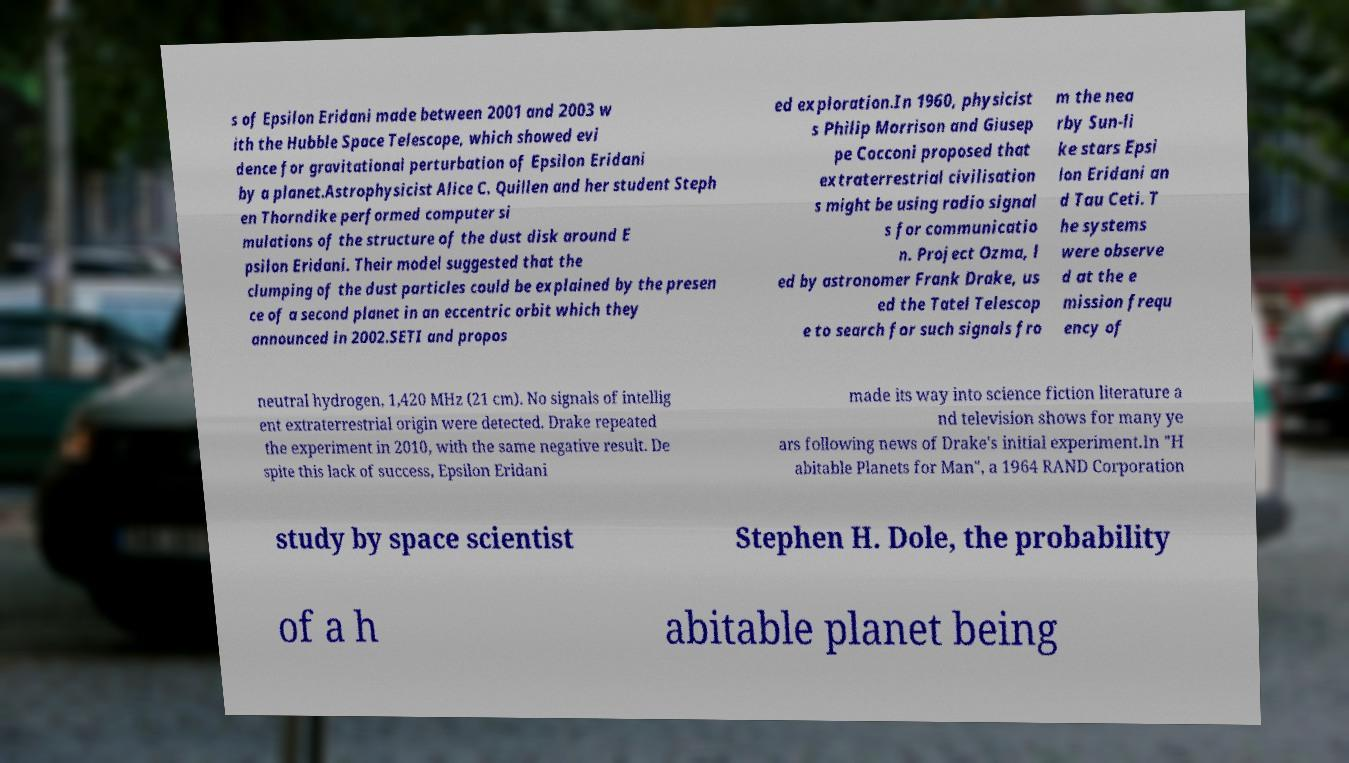What messages or text are displayed in this image? I need them in a readable, typed format. s of Epsilon Eridani made between 2001 and 2003 w ith the Hubble Space Telescope, which showed evi dence for gravitational perturbation of Epsilon Eridani by a planet.Astrophysicist Alice C. Quillen and her student Steph en Thorndike performed computer si mulations of the structure of the dust disk around E psilon Eridani. Their model suggested that the clumping of the dust particles could be explained by the presen ce of a second planet in an eccentric orbit which they announced in 2002.SETI and propos ed exploration.In 1960, physicist s Philip Morrison and Giusep pe Cocconi proposed that extraterrestrial civilisation s might be using radio signal s for communicatio n. Project Ozma, l ed by astronomer Frank Drake, us ed the Tatel Telescop e to search for such signals fro m the nea rby Sun-li ke stars Epsi lon Eridani an d Tau Ceti. T he systems were observe d at the e mission frequ ency of neutral hydrogen, 1,420 MHz (21 cm). No signals of intellig ent extraterrestrial origin were detected. Drake repeated the experiment in 2010, with the same negative result. De spite this lack of success, Epsilon Eridani made its way into science fiction literature a nd television shows for many ye ars following news of Drake's initial experiment.In "H abitable Planets for Man", a 1964 RAND Corporation study by space scientist Stephen H. Dole, the probability of a h abitable planet being 